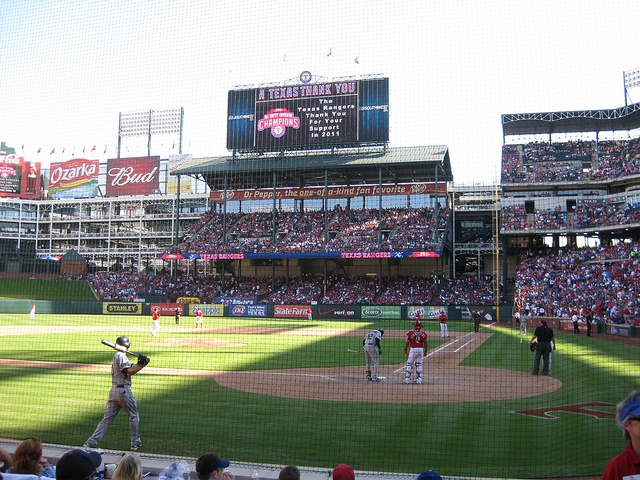Describe the objects in this image and their specific colors. I can see people in lightblue, black, gray, darkgray, and navy tones, people in lightblue, gray, black, and darkgreen tones, people in lightblue, maroon, black, navy, and gray tones, people in lightblue, maroon, gray, and black tones, and people in lightblue, black, gray, and maroon tones in this image. 